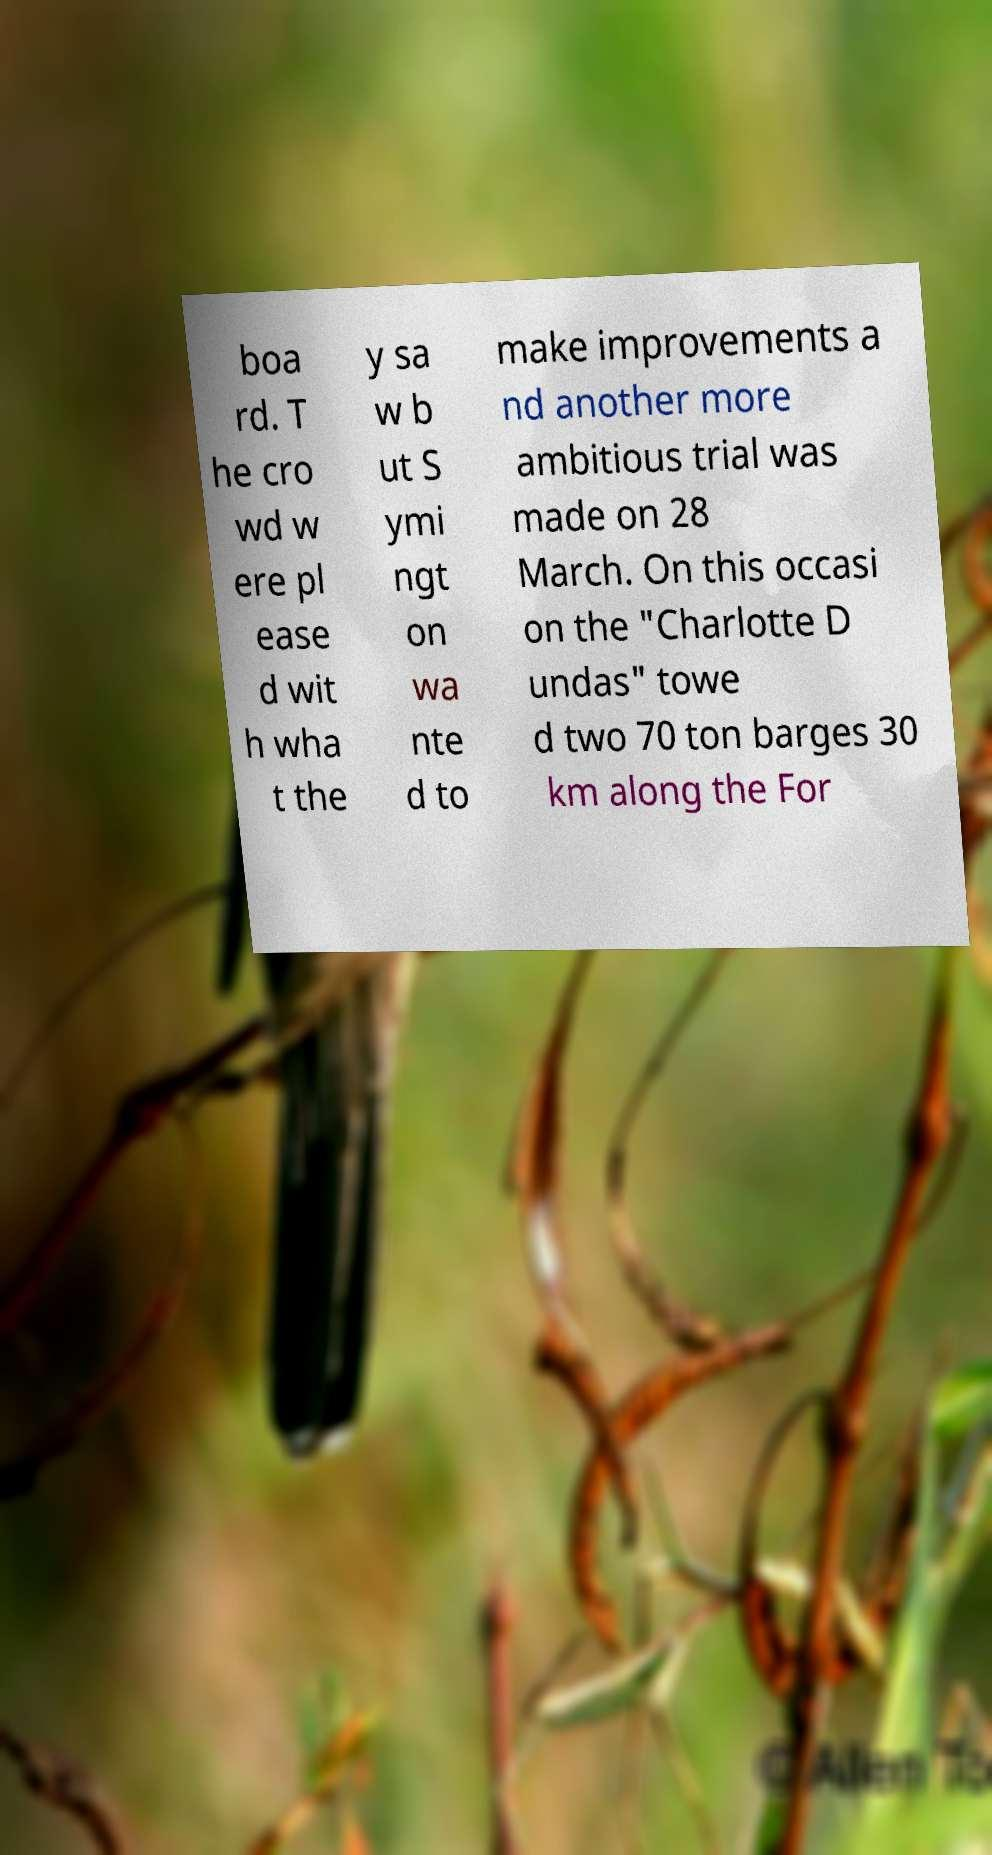I need the written content from this picture converted into text. Can you do that? boa rd. T he cro wd w ere pl ease d wit h wha t the y sa w b ut S ymi ngt on wa nte d to make improvements a nd another more ambitious trial was made on 28 March. On this occasi on the "Charlotte D undas" towe d two 70 ton barges 30 km along the For 